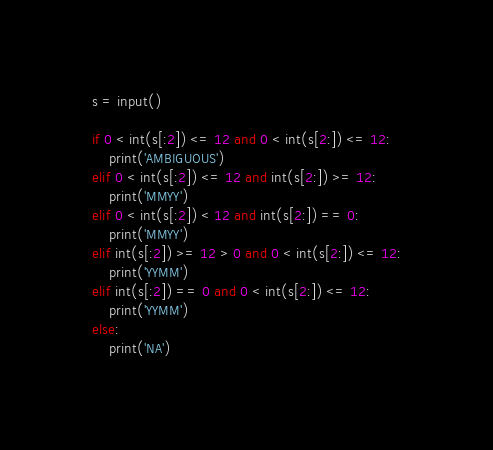<code> <loc_0><loc_0><loc_500><loc_500><_Python_>s = input()

if 0 < int(s[:2]) <= 12 and 0 < int(s[2:]) <= 12:
    print('AMBIGUOUS')
elif 0 < int(s[:2]) <= 12 and int(s[2:]) >= 12:
    print('MMYY')
elif 0 < int(s[:2]) < 12 and int(s[2:]) == 0:
    print('MMYY')
elif int(s[:2]) >= 12 > 0 and 0 < int(s[2:]) <= 12:
    print('YYMM')
elif int(s[:2]) == 0 and 0 < int(s[2:]) <= 12:
    print('YYMM')
else:
    print('NA')</code> 